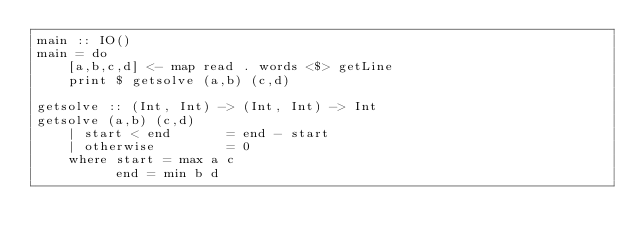<code> <loc_0><loc_0><loc_500><loc_500><_Haskell_>main :: IO()
main = do
    [a,b,c,d] <- map read . words <$> getLine
    print $ getsolve (a,b) (c,d)
    
getsolve :: (Int, Int) -> (Int, Int) -> Int
getsolve (a,b) (c,d)
    | start < end		= end - start 
    | otherwise			= 0
    where start = max a c
          end = min b d</code> 